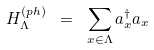<formula> <loc_0><loc_0><loc_500><loc_500>H _ { \Lambda } ^ { ( p h ) } \ = \ \sum _ { x \in \Lambda } a _ { x } ^ { \dagger } a _ { x }</formula> 